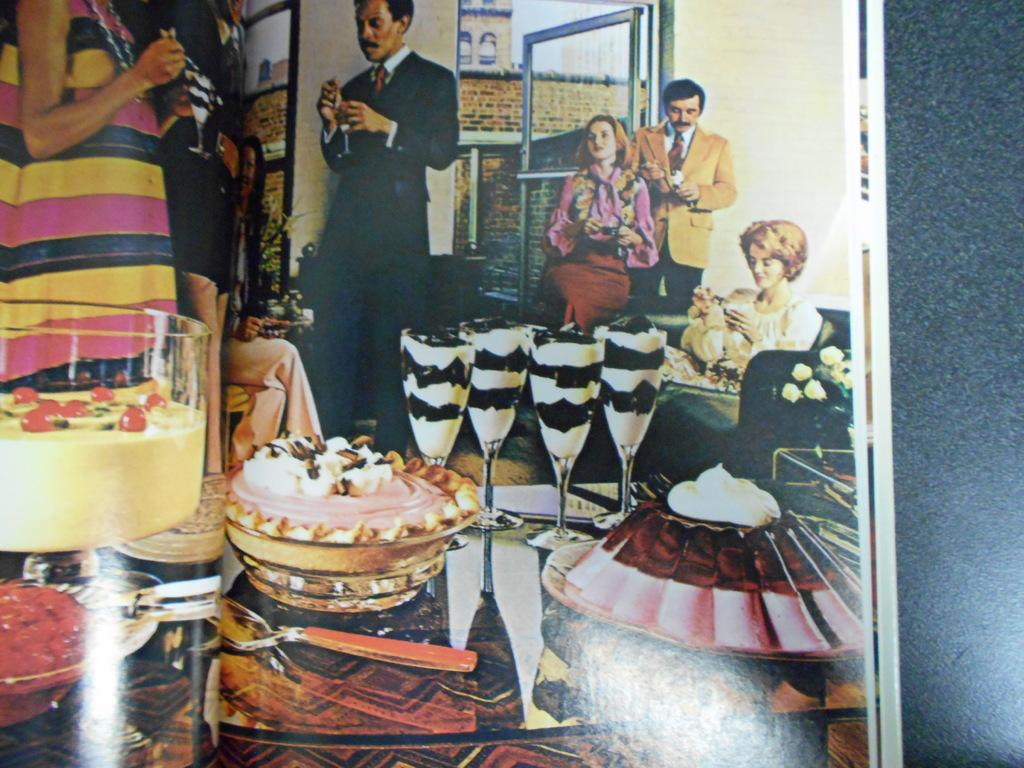What is present on the surface in the image? There is a photo on the surface in the image. What can be seen in the photo? The photo contains people, glasses, spoons, food items, a sofa, a door, walls, and other objects. Can you describe the people in the photo? The provided facts do not give specific details about the people in the photo. What type of objects are present in the photo? The photo contains glasses, spoons, a sofa, a door, walls, and other objects. How does the zephyr affect the holiday in the image? There is no mention of a zephyr or a holiday in the image. The image only contains a photo with various elements, as described in the conversation. 